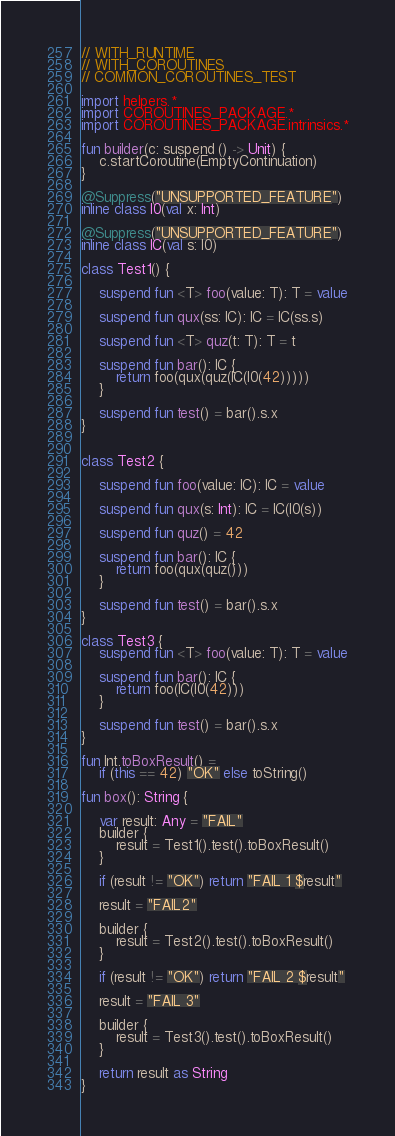Convert code to text. <code><loc_0><loc_0><loc_500><loc_500><_Kotlin_>// WITH_RUNTIME
// WITH_COROUTINES
// COMMON_COROUTINES_TEST

import helpers.*
import COROUTINES_PACKAGE.*
import COROUTINES_PACKAGE.intrinsics.*

fun builder(c: suspend () -> Unit) {
    c.startCoroutine(EmptyContinuation)
}

@Suppress("UNSUPPORTED_FEATURE")
inline class I0(val x: Int)

@Suppress("UNSUPPORTED_FEATURE")
inline class IC(val s: I0)

class Test1() {

    suspend fun <T> foo(value: T): T = value

    suspend fun qux(ss: IC): IC = IC(ss.s)

    suspend fun <T> quz(t: T): T = t

    suspend fun bar(): IC {
        return foo(qux(quz(IC(I0(42)))))
    }

    suspend fun test() = bar().s.x
}


class Test2 {

    suspend fun foo(value: IC): IC = value

    suspend fun qux(s: Int): IC = IC(I0(s))

    suspend fun quz() = 42

    suspend fun bar(): IC {
        return foo(qux(quz()))
    }

    suspend fun test() = bar().s.x
}

class Test3 {
    suspend fun <T> foo(value: T): T = value

    suspend fun bar(): IC {
        return foo(IC(I0(42)))
    }

    suspend fun test() = bar().s.x
}

fun Int.toBoxResult() =
    if (this == 42) "OK" else toString()

fun box(): String {

    var result: Any = "FAIL"
    builder {
        result = Test1().test().toBoxResult()
    }

    if (result != "OK") return "FAIL 1 $result"

    result = "FAIL2"

    builder {
        result = Test2().test().toBoxResult()
    }

    if (result != "OK") return "FAIL 2 $result"

    result = "FAIL 3"

    builder {
        result = Test3().test().toBoxResult()
    }

    return result as String
}
</code> 